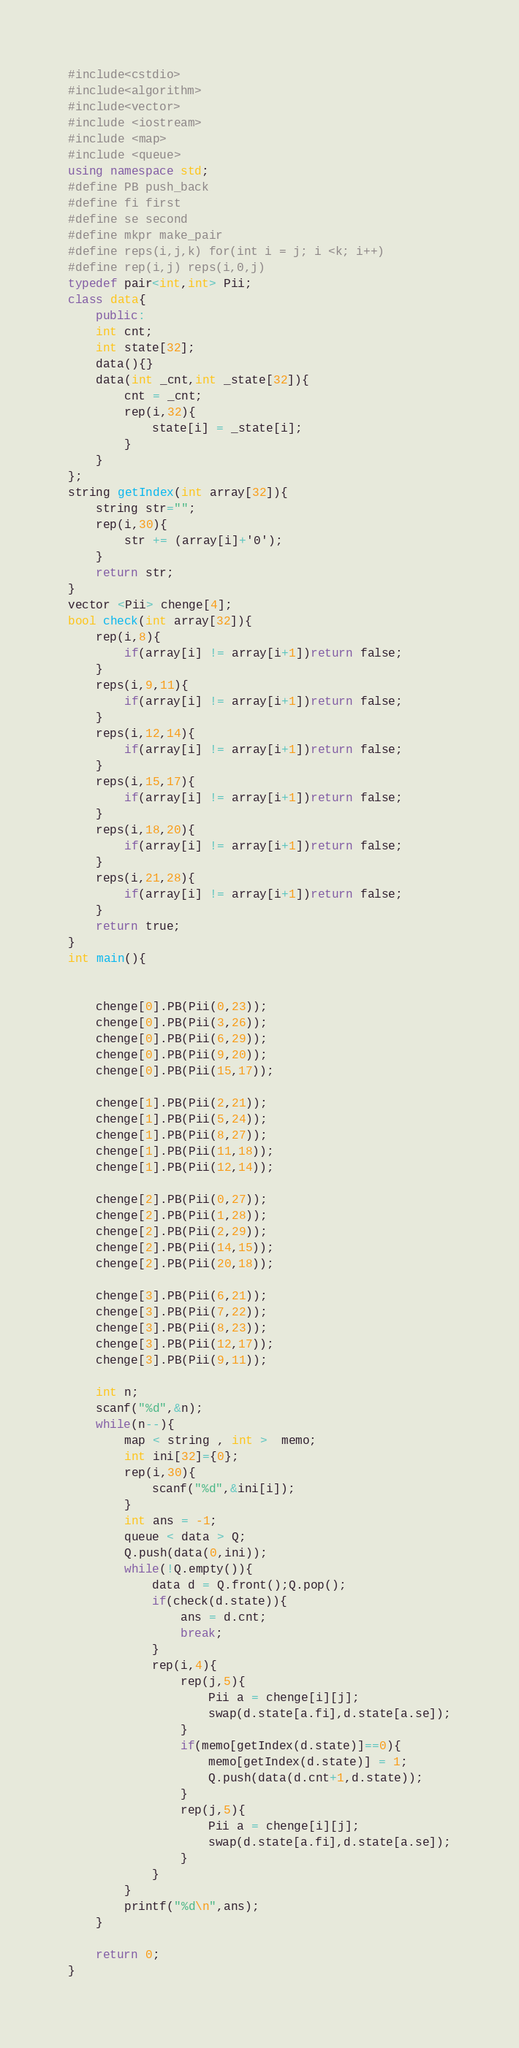<code> <loc_0><loc_0><loc_500><loc_500><_C++_>#include<cstdio>
#include<algorithm>
#include<vector>
#include <iostream>
#include <map>
#include <queue>
using namespace std;
#define PB push_back
#define fi first
#define se second
#define mkpr make_pair
#define reps(i,j,k) for(int i = j; i <k; i++)
#define rep(i,j) reps(i,0,j)
typedef pair<int,int> Pii;
class data{
    public:
    int cnt;
    int state[32];
    data(){}
    data(int _cnt,int _state[32]){
        cnt = _cnt;
        rep(i,32){
            state[i] = _state[i];
        }
    }
};
string getIndex(int array[32]){
    string str="";
    rep(i,30){
        str += (array[i]+'0');
    }
    return str;
}
vector <Pii> chenge[4];
bool check(int array[32]){
    rep(i,8){
        if(array[i] != array[i+1])return false;
    }
    reps(i,9,11){
        if(array[i] != array[i+1])return false;
    }
    reps(i,12,14){
        if(array[i] != array[i+1])return false;
    }
    reps(i,15,17){
        if(array[i] != array[i+1])return false;
    }
    reps(i,18,20){
        if(array[i] != array[i+1])return false;
    }
    reps(i,21,28){
        if(array[i] != array[i+1])return false;
    }
    return true;
}
int main(){


    chenge[0].PB(Pii(0,23));
    chenge[0].PB(Pii(3,26));
    chenge[0].PB(Pii(6,29));
    chenge[0].PB(Pii(9,20));
    chenge[0].PB(Pii(15,17));

    chenge[1].PB(Pii(2,21));
    chenge[1].PB(Pii(5,24));
    chenge[1].PB(Pii(8,27));
    chenge[1].PB(Pii(11,18));
    chenge[1].PB(Pii(12,14));

    chenge[2].PB(Pii(0,27));
    chenge[2].PB(Pii(1,28));
    chenge[2].PB(Pii(2,29));
    chenge[2].PB(Pii(14,15));
    chenge[2].PB(Pii(20,18));

    chenge[3].PB(Pii(6,21));
    chenge[3].PB(Pii(7,22));
    chenge[3].PB(Pii(8,23));
    chenge[3].PB(Pii(12,17));
    chenge[3].PB(Pii(9,11));

    int n;
    scanf("%d",&n);
    while(n--){
        map < string , int >  memo;
        int ini[32]={0};
        rep(i,30){
            scanf("%d",&ini[i]);
        }
        int ans = -1;
        queue < data > Q;
        Q.push(data(0,ini));
        while(!Q.empty()){
            data d = Q.front();Q.pop();
            if(check(d.state)){
                ans = d.cnt;
                break;
            }
            rep(i,4){
                rep(j,5){
                    Pii a = chenge[i][j];
                    swap(d.state[a.fi],d.state[a.se]);
                }
                if(memo[getIndex(d.state)]==0){
                    memo[getIndex(d.state)] = 1;
                    Q.push(data(d.cnt+1,d.state));
                }
                rep(j,5){
                    Pii a = chenge[i][j];
                    swap(d.state[a.fi],d.state[a.se]);
                }
            }
        }
        printf("%d\n",ans);
    }

    return 0;
}</code> 